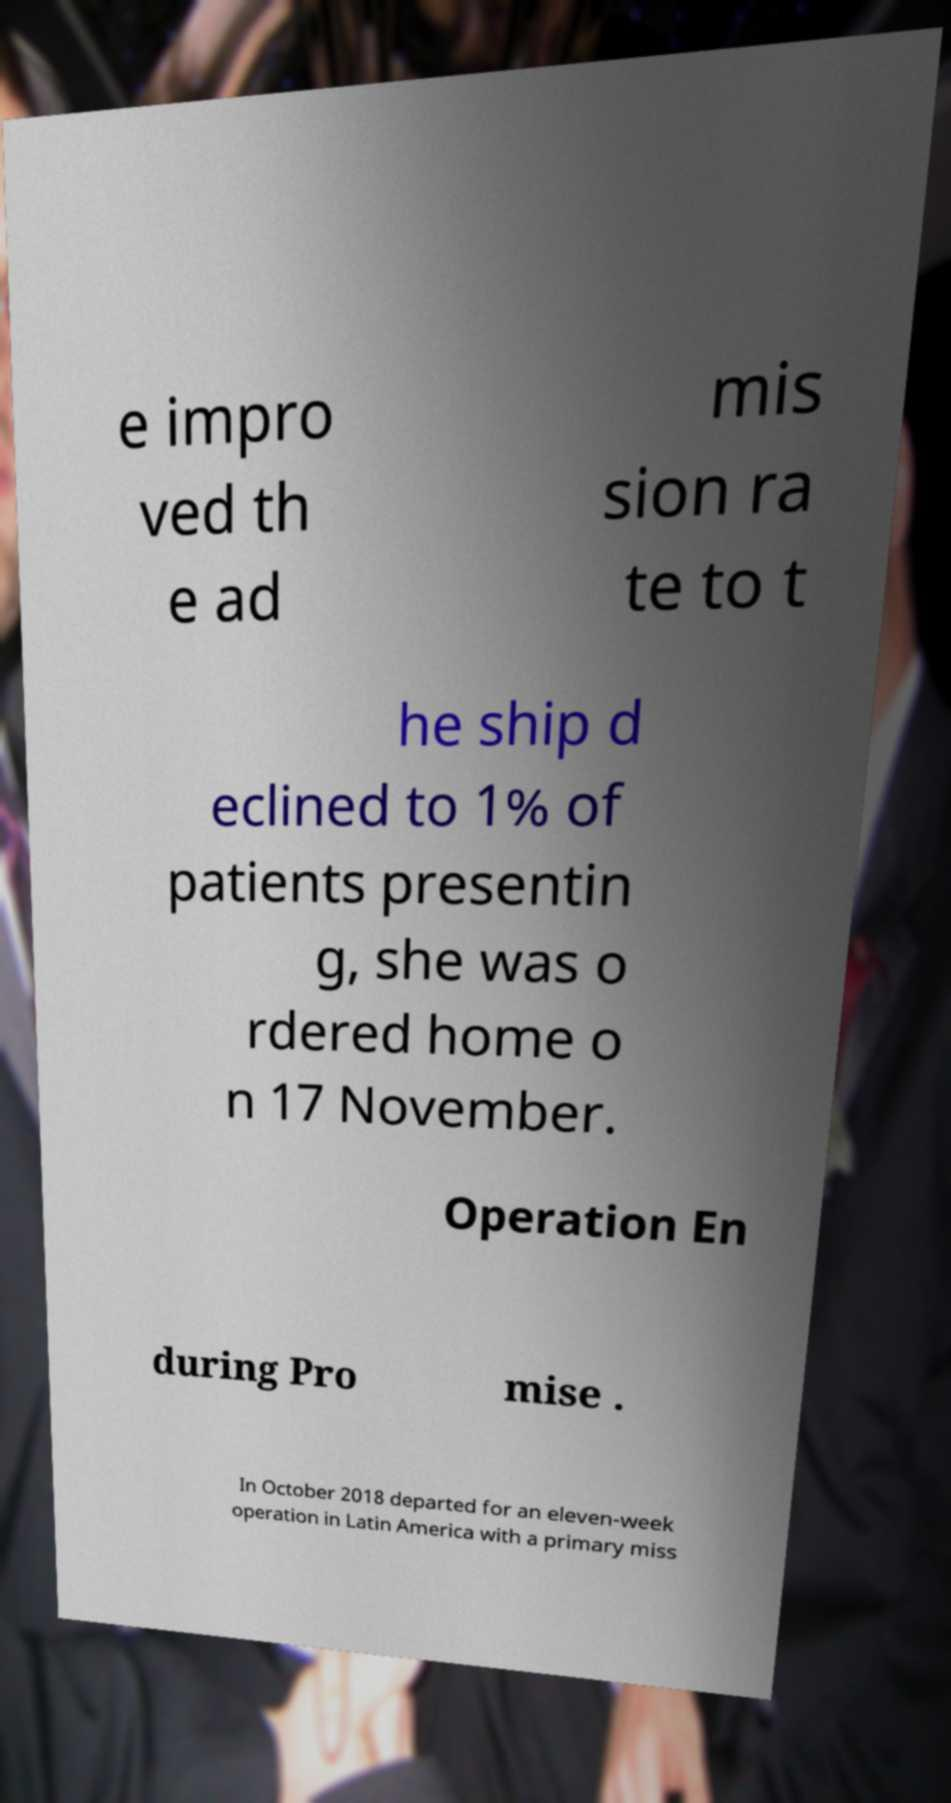Please read and relay the text visible in this image. What does it say? e impro ved th e ad mis sion ra te to t he ship d eclined to 1% of patients presentin g, she was o rdered home o n 17 November. Operation En during Pro mise . In October 2018 departed for an eleven-week operation in Latin America with a primary miss 